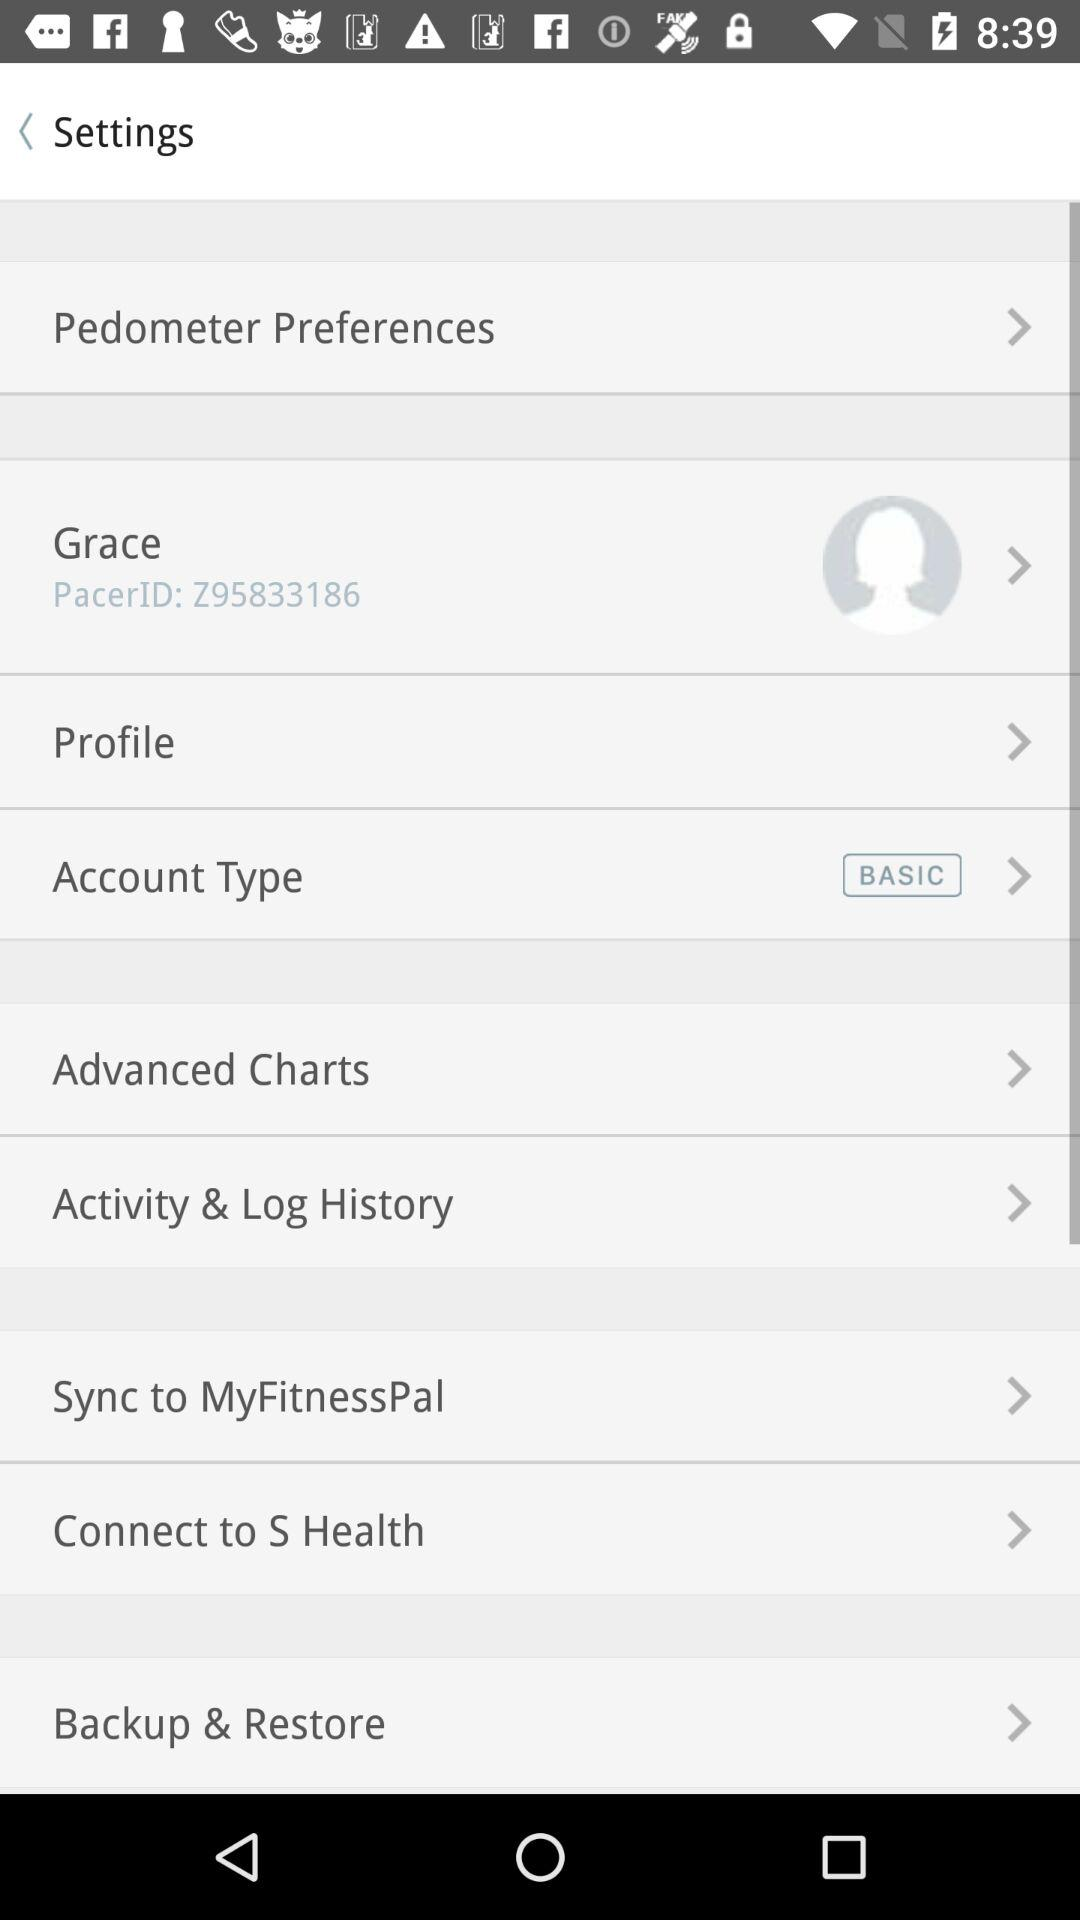What is the name of the user? The name of the user is Grace. 